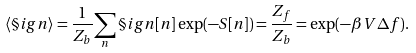<formula> <loc_0><loc_0><loc_500><loc_500>\langle \S i g n \rangle = \frac { 1 } { Z _ { b } } { \sum _ { n } \S i g n [ n ] \exp ( - S [ n ] ) } = \frac { Z _ { f } } { Z _ { b } } = \exp ( - \beta V \Delta f ) .</formula> 